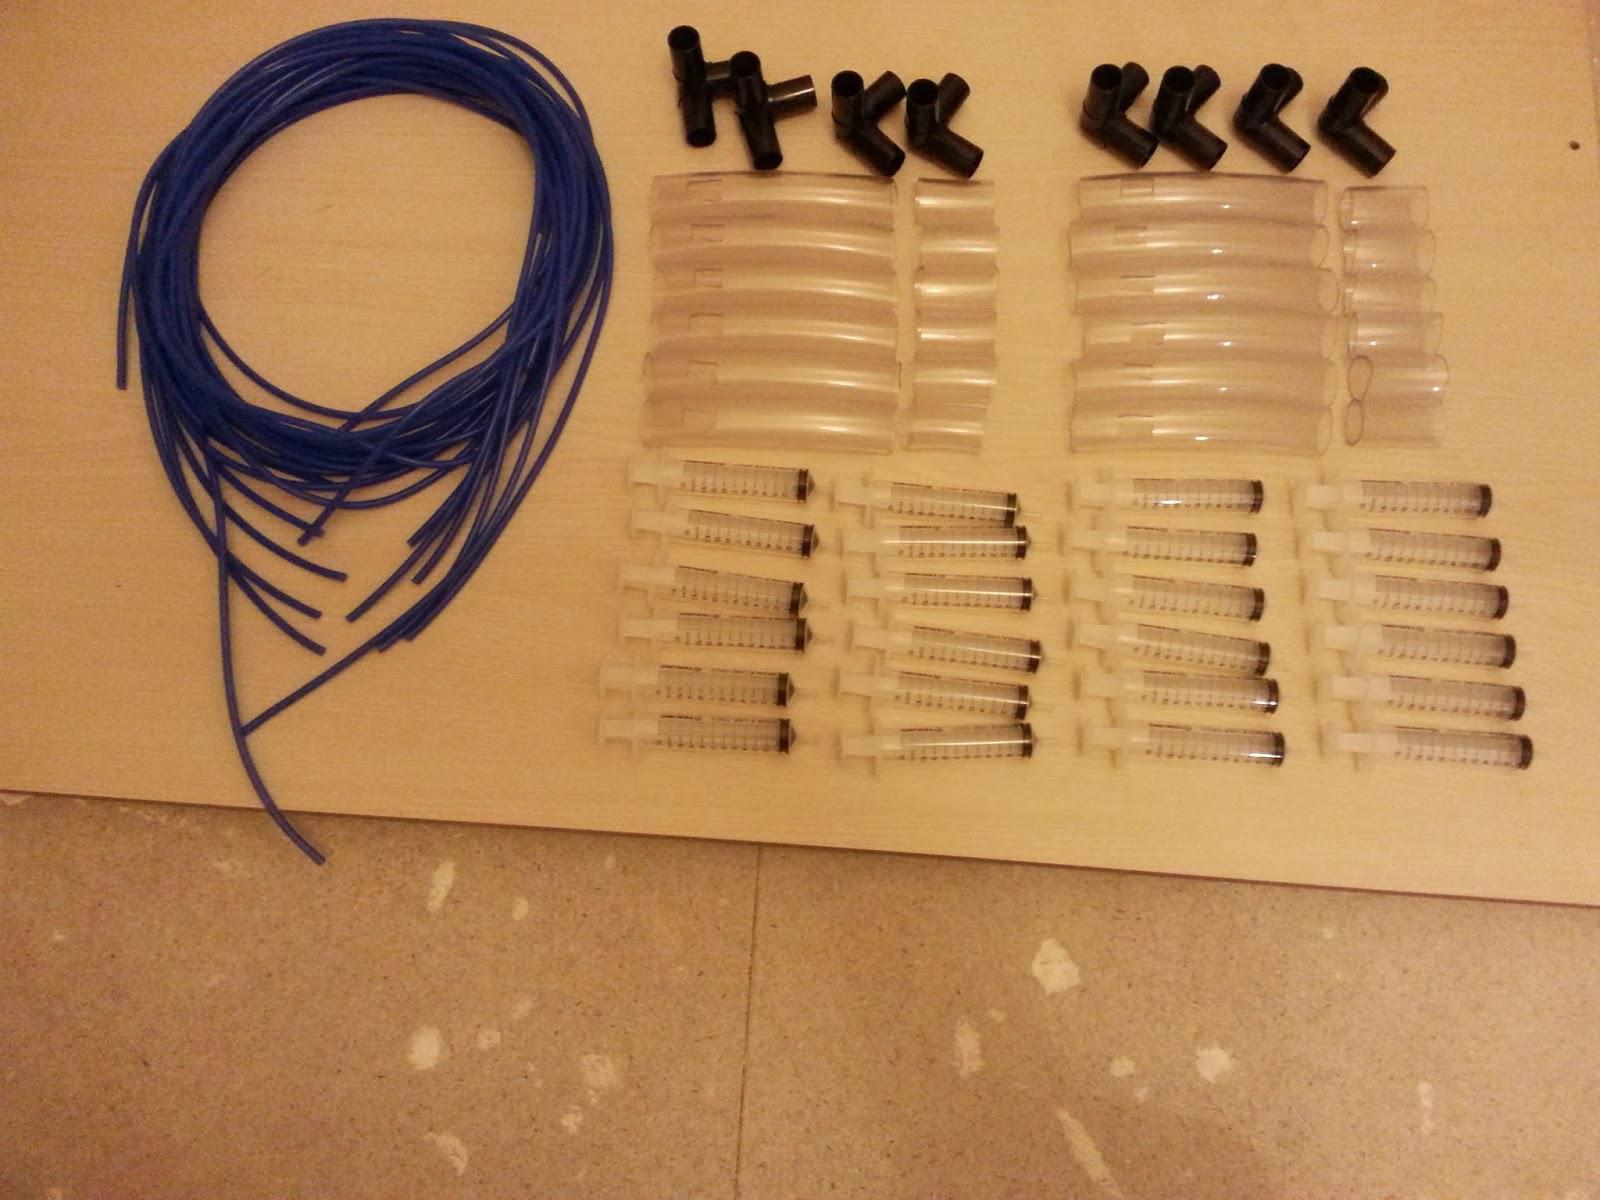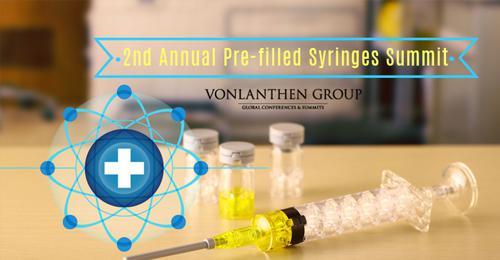The first image is the image on the left, the second image is the image on the right. Assess this claim about the two images: "The left image shows a clear cylinder with colored plastic on each end, and the right image shows something with a rightward-facing point". Correct or not? Answer yes or no. No. 